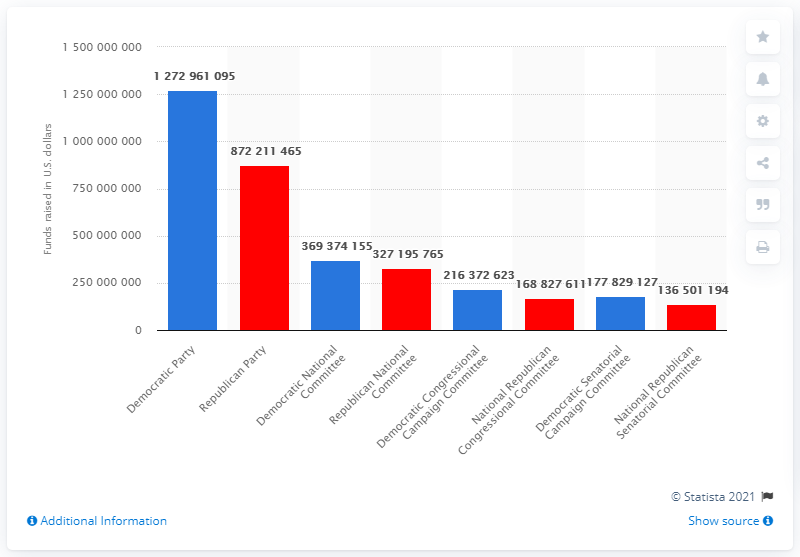Outline some significant characteristics in this image. The Democratic Party raised a significant amount of money during the 2016 election cycle, totaling 12,729,610,955. 